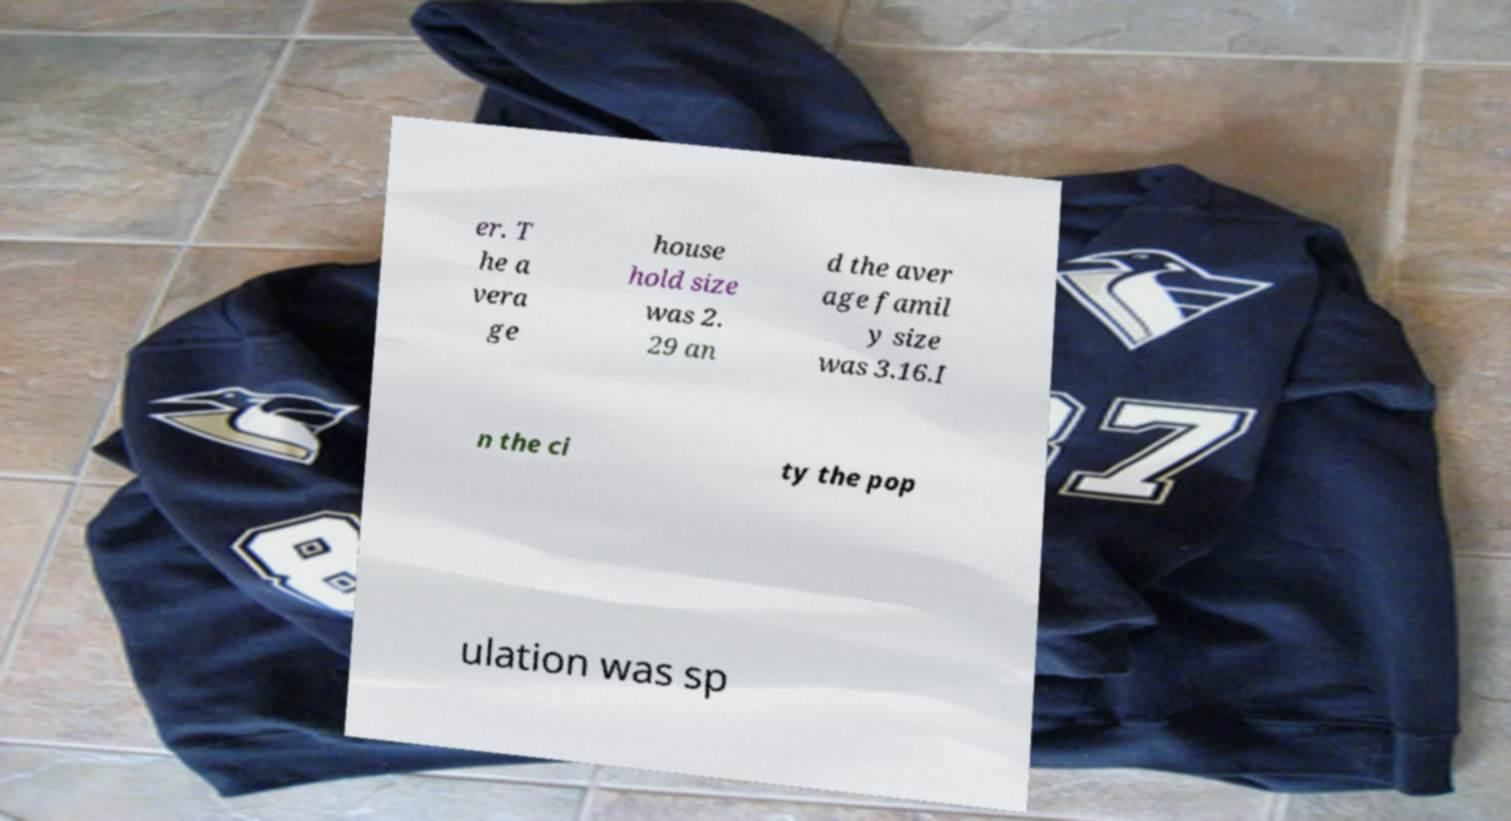For documentation purposes, I need the text within this image transcribed. Could you provide that? er. T he a vera ge house hold size was 2. 29 an d the aver age famil y size was 3.16.I n the ci ty the pop ulation was sp 